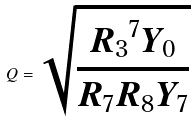<formula> <loc_0><loc_0><loc_500><loc_500>Q = \sqrt { \frac { { R _ { 3 } } ^ { 7 } Y _ { 0 } } { R _ { 7 } R _ { 8 } Y _ { 7 } } }</formula> 